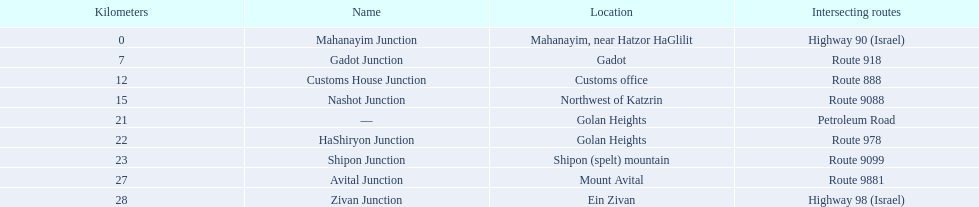What junction is the furthest from mahanayim junction? Zivan Junction. 